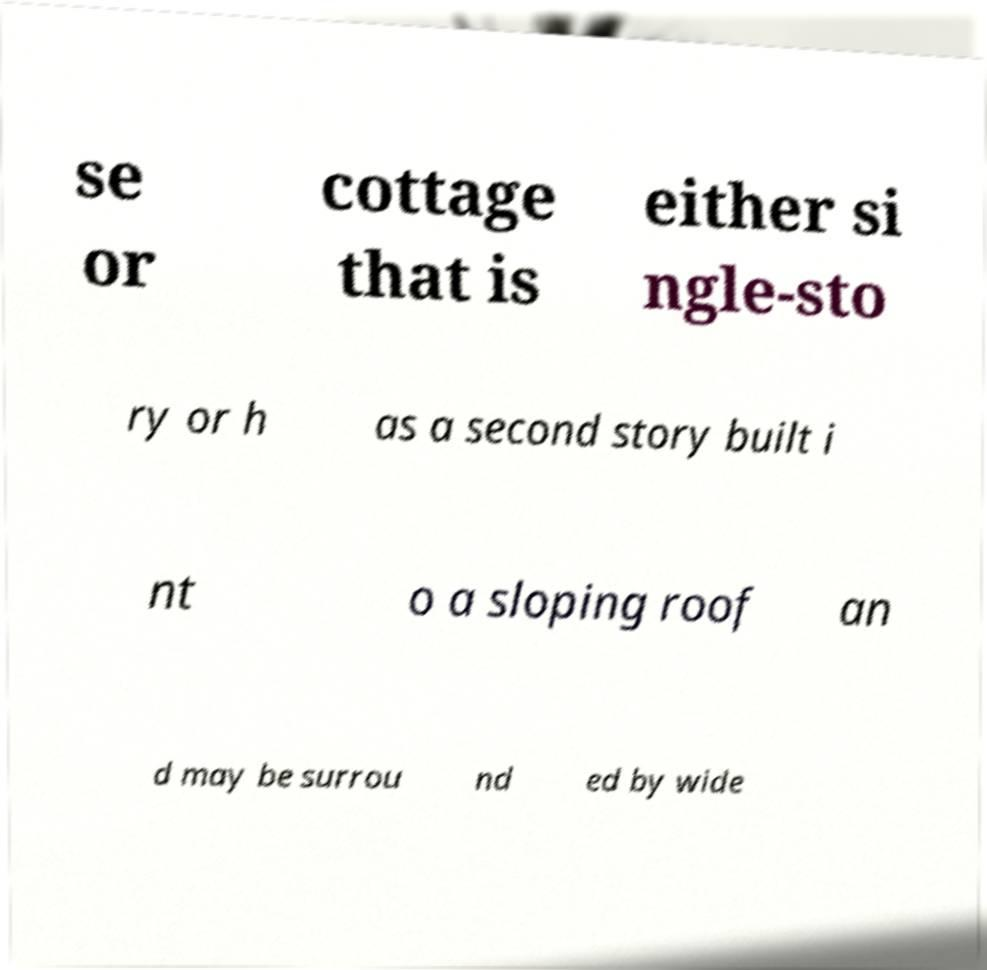Could you assist in decoding the text presented in this image and type it out clearly? se or cottage that is either si ngle-sto ry or h as a second story built i nt o a sloping roof an d may be surrou nd ed by wide 